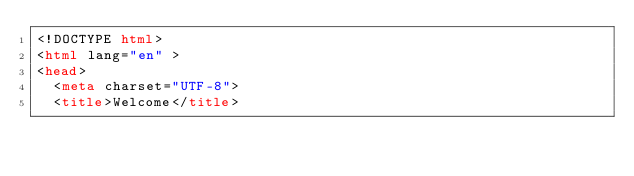<code> <loc_0><loc_0><loc_500><loc_500><_HTML_><!DOCTYPE html>
<html lang="en" >
<head>
  <meta charset="UTF-8">
  <title>Welcome</title></code> 